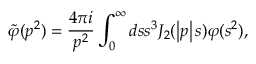Convert formula to latex. <formula><loc_0><loc_0><loc_500><loc_500>\widetilde { \varphi } ( p ^ { 2 } ) = \frac { 4 \pi i } { p ^ { 2 } } \int _ { 0 } ^ { \infty } d s s ^ { 3 } J _ { 2 } ( \left | p \right | s ) \varphi ( s ^ { 2 } ) ,</formula> 